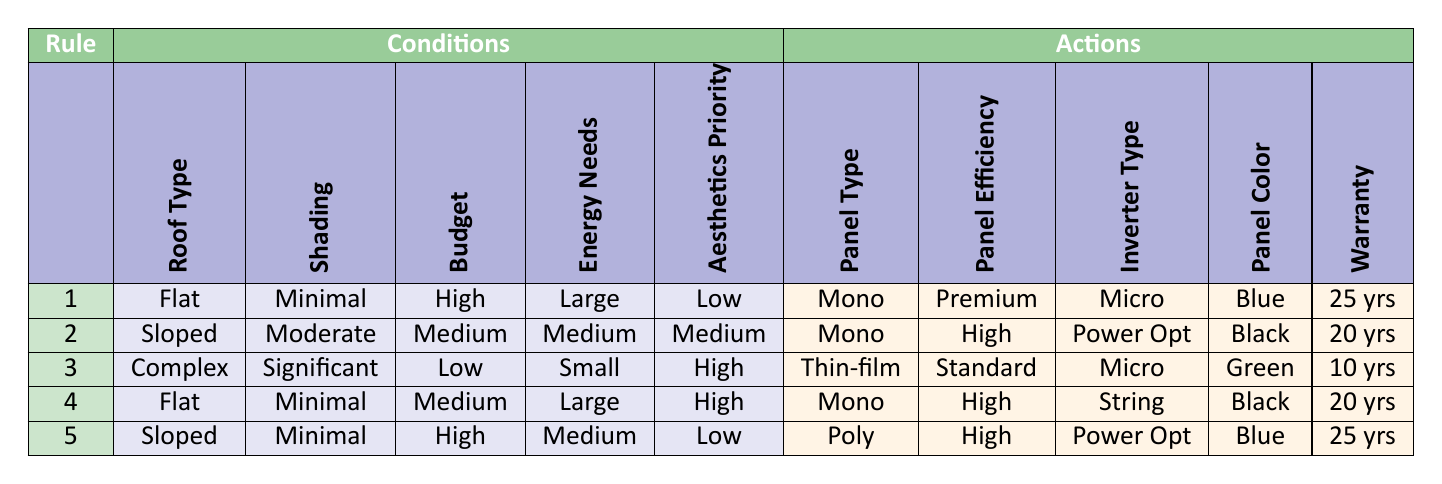What type of solar panel should be used for a flat roof with minimal shading and high budget? From the table, rule 1 indicates that for a flat roof with minimal shading and a high budget, the suitable panel type is Monocrystalline.
Answer: Monocrystalline What is the warranty for a sloped roof installation with medium energy needs and a medium budget? By examining rule 2, for a sloped roof with medium energy needs and a medium budget, the warranty is 20 years.
Answer: 20 years Are polycrystalline panels recommended for significant shading and small energy needs? Looking at the table, there are no rules for polycrystalline panels under the conditions of significant shading and small energy needs, which makes the answer no.
Answer: No What is the panel efficiency for a flat roof with minimal shading, a large energy need, and low aesthetics priority? Rule 1 specifies that the panel efficiency is Premium, which exceeds 20 percent for that particular condition.
Answer: Premium If we add the warranties for the installations in rules 1 and 2, what is the total? The warranties in rules 1 (25 years) and 2 (20 years) are summed up as 25 + 20 = 45 years.
Answer: 45 years Is there a rule that suggests using thin-film panels for significant shading under low budget constraints? The table shows that for significant shading and a low budget, rule 3 suggests thin-film panels, so the answer is yes.
Answer: Yes What color is suggested for a sloped roof with minimal shading and a high budget installation? According to rule 5, the suggested panel color for a sloped roof with minimal shading and a high budget is Blue.
Answer: Blue What is the type of inverter recommended for a flat roof with a medium budget and large energy needs? From rule 4, the inverter type recommended is a String inverter for a flat roof with a medium budget and large energy needs.
Answer: String In which situation is a green panel color recommended? The table indicates that a green panel color is recommended in rule 3, which covers a complex roof type, significant shading, a low budget, small energy needs, and high aesthetics priority.
Answer: Complex roof, significant shading, low budget, small energy needs, high aesthetics priority 